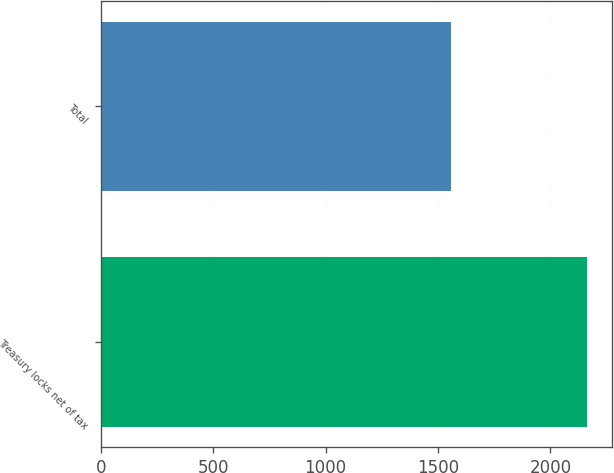Convert chart to OTSL. <chart><loc_0><loc_0><loc_500><loc_500><bar_chart><fcel>Treasury locks net of tax<fcel>Total<nl><fcel>2164<fcel>1557<nl></chart> 